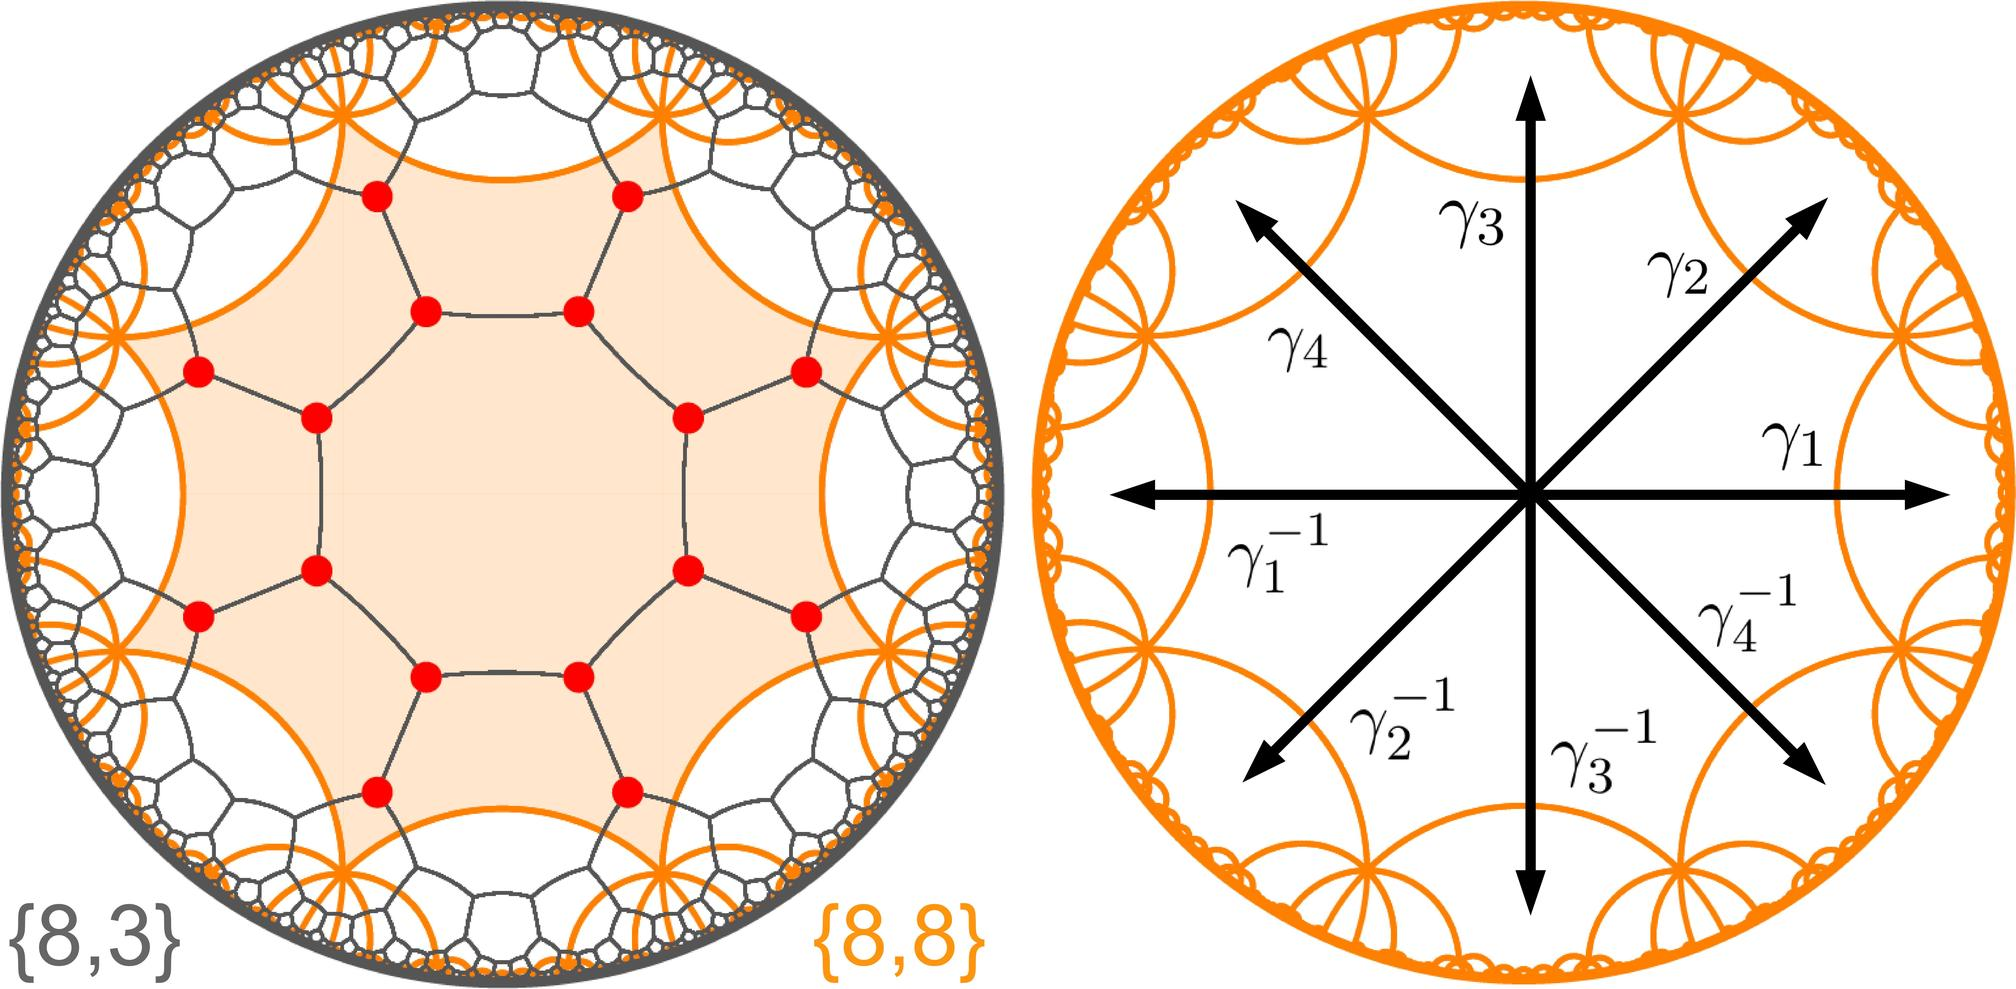What can the arrangement of the roots and their negatives tell us about the characteristics of the polynomial they solve? The symmetrical arrangement of the roots and their negatives around the origin suggests that the polynomial has real coefficients. When a polynomial has real coefficients, any non-real roots must occur in conjugate pairs. Here, the polynomial likely exhibits specific symmetrical properties, indicating not only real coefficients but also the presence of special symmetrical structures within the polynomial, which may hint at additional underlying physical or geometric principles guiding their distribution. Could the placement of these roots indicate any specific type of polynomial? Yes, the placement of these roots, especially in a uniform circular distribution, can indicate a special category of polynomials called cyclotomic polynomials. These polynomials have roots that are the primitive roots of unity and are evenly spaced around the unit circle in the complex plane. They play a significant role in number theory, particularly in constructing regular polygons and in proofs related to prime numbers and their properties. 